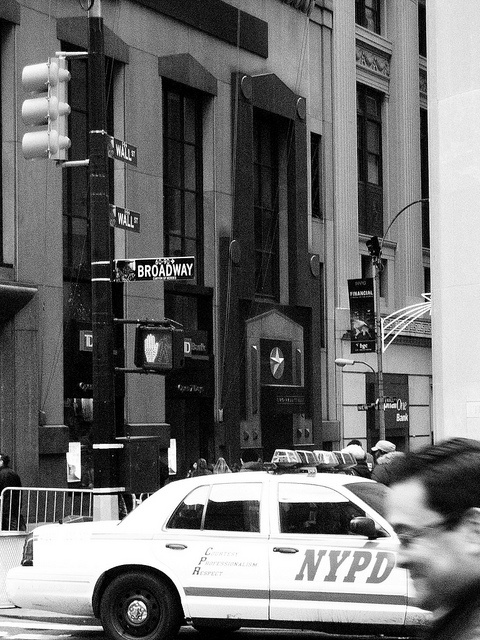Describe the objects in this image and their specific colors. I can see car in black, white, darkgray, and gray tones, people in black, gray, darkgray, and lightgray tones, traffic light in black, darkgray, lightgray, and gray tones, people in black, gray, darkgray, and lightgray tones, and people in black, white, gray, and darkgray tones in this image. 